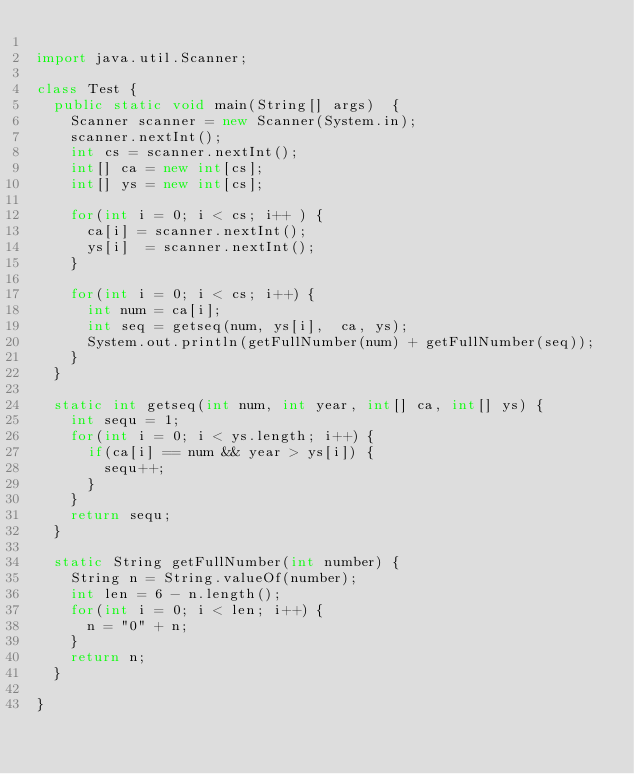Convert code to text. <code><loc_0><loc_0><loc_500><loc_500><_Java_>
import java.util.Scanner;

class Test {	
	public static void main(String[] args)  {		
		Scanner scanner = new Scanner(System.in);
		scanner.nextInt();
		int cs = scanner.nextInt();
		int[] ca = new int[cs];
		int[] ys = new int[cs];
		
		for(int i = 0; i < cs; i++ ) {
			ca[i] = scanner.nextInt();
			ys[i]  = scanner.nextInt();
		}
		
		for(int i = 0; i < cs; i++) {
			int num = ca[i];
			int seq = getseq(num, ys[i],  ca, ys);
			System.out.println(getFullNumber(num) + getFullNumber(seq));
		}
	}
	
	static int getseq(int num, int year, int[] ca, int[] ys) {
		int sequ = 1;
		for(int i = 0; i < ys.length; i++) {
			if(ca[i] == num && year > ys[i]) {
				sequ++;
			}
		}
		return sequ;
	}

	static String getFullNumber(int number) {
		String n = String.valueOf(number);
		int len = 6 - n.length();
		for(int i = 0; i < len; i++) {
			n = "0" + n;
		}
		return n;
	}

}</code> 